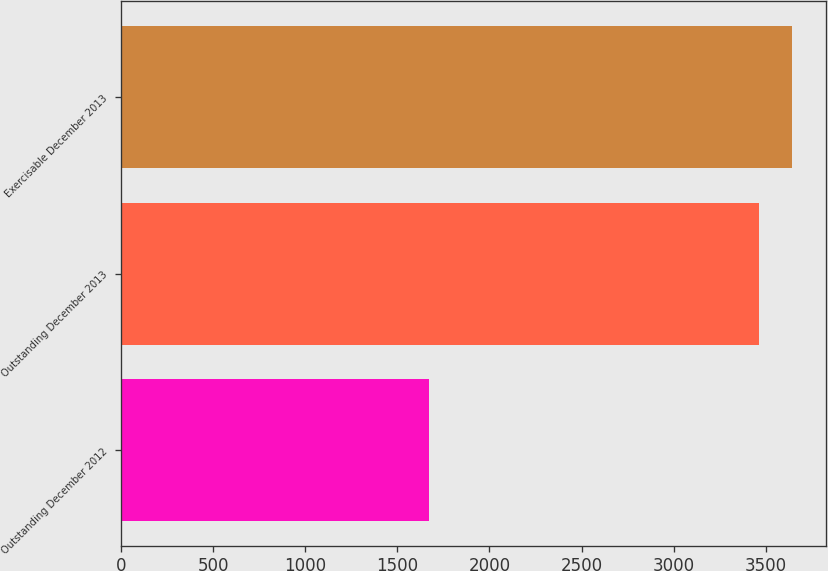Convert chart. <chart><loc_0><loc_0><loc_500><loc_500><bar_chart><fcel>Outstanding December 2012<fcel>Outstanding December 2013<fcel>Exercisable December 2013<nl><fcel>1672<fcel>3465<fcel>3644.3<nl></chart> 